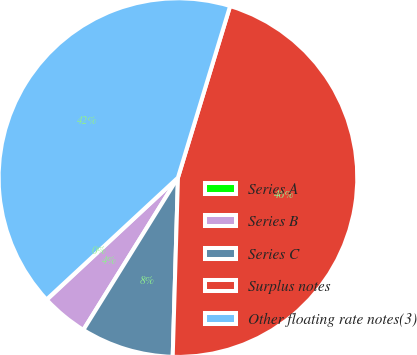Convert chart to OTSL. <chart><loc_0><loc_0><loc_500><loc_500><pie_chart><fcel>Series A<fcel>Series B<fcel>Series C<fcel>Surplus notes<fcel>Other floating rate notes(3)<nl><fcel>0.04%<fcel>4.21%<fcel>8.38%<fcel>45.77%<fcel>41.6%<nl></chart> 